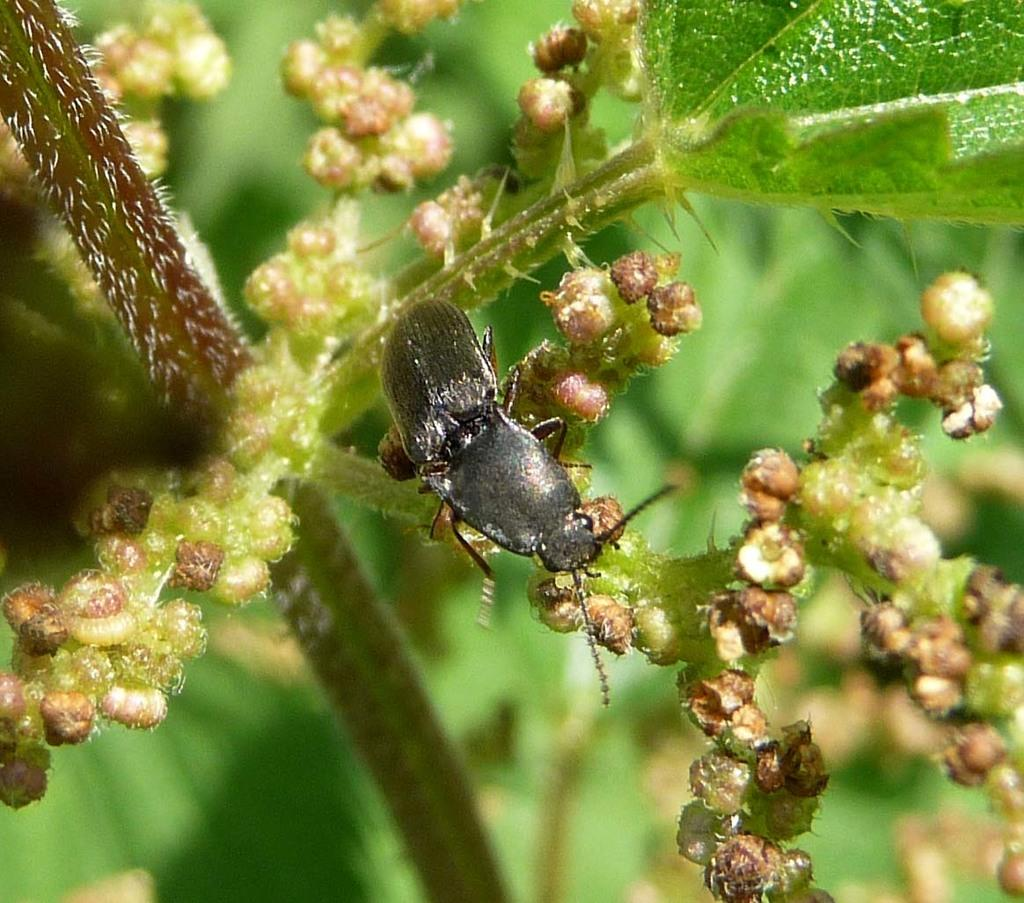What is the main subject of the image? There is a dung beetle in the center of the image. Where is the dung beetle located? The dung beetle is on a plant. Can you describe the background of the image? The background of the image is blurred. How many dinosaurs can be seen in the image? There are no dinosaurs present in the image. What type of spiders are crawling on the dung beetle in the image? There are no spiders present in the image, and the dung beetle is not interacting with any spiders. 